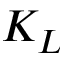<formula> <loc_0><loc_0><loc_500><loc_500>K _ { L }</formula> 